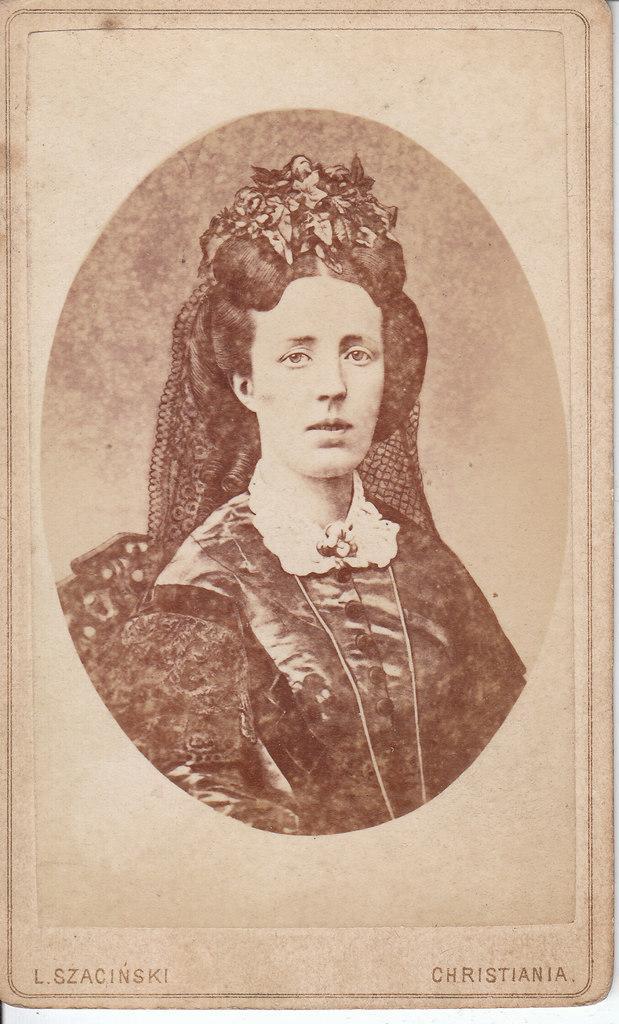In one or two sentences, can you explain what this image depicts? In this image we can see black and white photo of a lady. At the bottom of the image, text is written. 